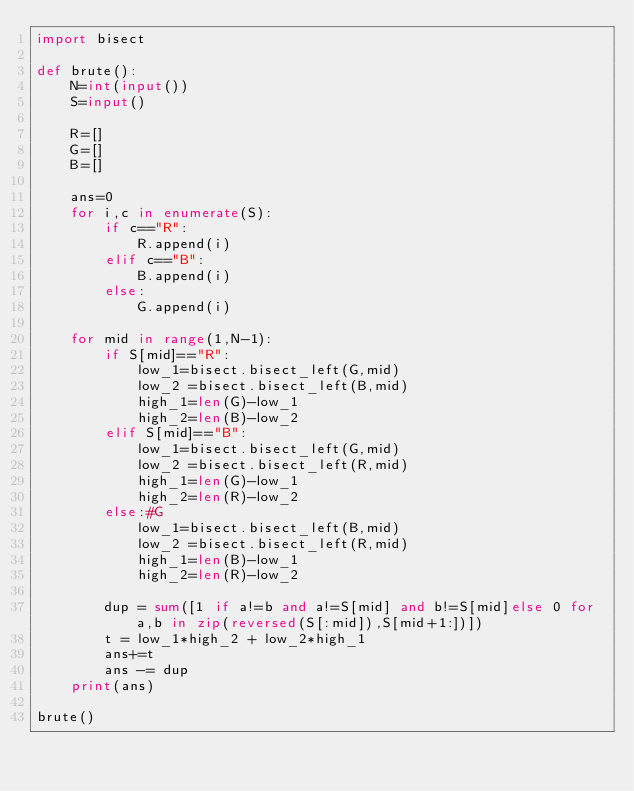Convert code to text. <code><loc_0><loc_0><loc_500><loc_500><_Python_>import bisect

def brute():
    N=int(input())
    S=input()

    R=[]
    G=[]
    B=[]

    ans=0
    for i,c in enumerate(S):
        if c=="R":
            R.append(i)
        elif c=="B":
            B.append(i)
        else:
            G.append(i)

    for mid in range(1,N-1):
        if S[mid]=="R":
            low_1=bisect.bisect_left(G,mid)
            low_2 =bisect.bisect_left(B,mid)
            high_1=len(G)-low_1
            high_2=len(B)-low_2
        elif S[mid]=="B":
            low_1=bisect.bisect_left(G,mid)
            low_2 =bisect.bisect_left(R,mid)
            high_1=len(G)-low_1
            high_2=len(R)-low_2
        else:#G
            low_1=bisect.bisect_left(B,mid)
            low_2 =bisect.bisect_left(R,mid)
            high_1=len(B)-low_1
            high_2=len(R)-low_2

        dup = sum([1 if a!=b and a!=S[mid] and b!=S[mid]else 0 for a,b in zip(reversed(S[:mid]),S[mid+1:])])
        t = low_1*high_2 + low_2*high_1
        ans+=t
        ans -= dup
    print(ans)

brute()
</code> 